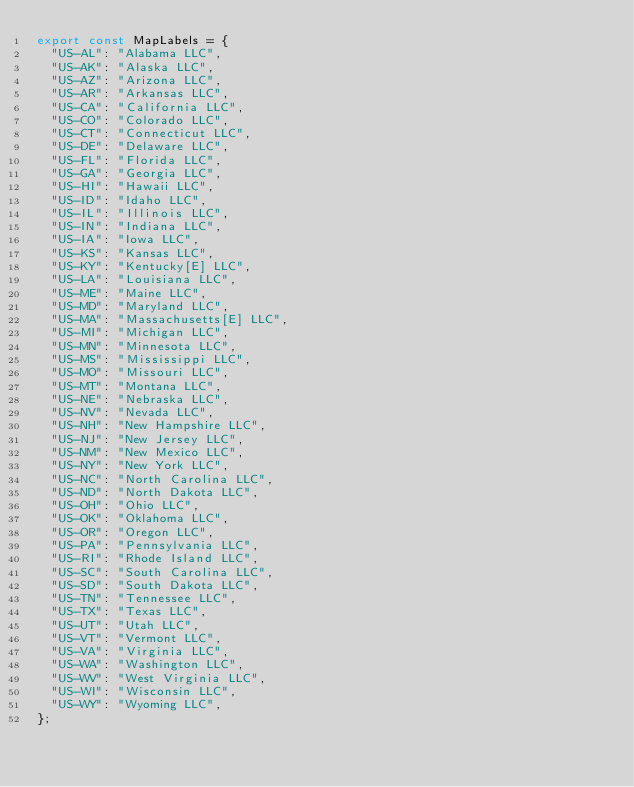<code> <loc_0><loc_0><loc_500><loc_500><_JavaScript_>export const MapLabels = {
  "US-AL": "Alabama LLC",
  "US-AK": "Alaska LLC",
  "US-AZ": "Arizona LLC",
  "US-AR": "Arkansas LLC",
  "US-CA": "California LLC",
  "US-CO": "Colorado LLC",
  "US-CT": "Connecticut LLC",
  "US-DE": "Delaware LLC",
  "US-FL": "Florida LLC",
  "US-GA": "Georgia LLC",
  "US-HI": "Hawaii LLC",
  "US-ID": "Idaho LLC",
  "US-IL": "Illinois LLC",
  "US-IN": "Indiana LLC",
  "US-IA": "Iowa LLC",
  "US-KS": "Kansas LLC",
  "US-KY": "Kentucky[E] LLC",
  "US-LA": "Louisiana LLC",
  "US-ME": "Maine LLC",
  "US-MD": "Maryland LLC",
  "US-MA": "Massachusetts[E] LLC",
  "US-MI": "Michigan LLC",
  "US-MN": "Minnesota LLC",
  "US-MS": "Mississippi LLC",
  "US-MO": "Missouri LLC",
  "US-MT": "Montana LLC",
  "US-NE": "Nebraska LLC",
  "US-NV": "Nevada LLC",
  "US-NH": "New Hampshire LLC",
  "US-NJ": "New Jersey LLC",
  "US-NM": "New Mexico LLC",
  "US-NY": "New York LLC",
  "US-NC": "North Carolina LLC",
  "US-ND": "North Dakota LLC",
  "US-OH": "Ohio LLC",
  "US-OK": "Oklahoma LLC",
  "US-OR": "Oregon LLC",
  "US-PA": "Pennsylvania LLC",
  "US-RI": "Rhode Island LLC",
  "US-SC": "South Carolina LLC",
  "US-SD": "South Dakota LLC",
  "US-TN": "Tennessee LLC",
  "US-TX": "Texas LLC",
  "US-UT": "Utah LLC",
  "US-VT": "Vermont LLC",
  "US-VA": "Virginia LLC",
  "US-WA": "Washington LLC",
  "US-WV": "West Virginia LLC",
  "US-WI": "Wisconsin LLC",
  "US-WY": "Wyoming LLC",
};
</code> 